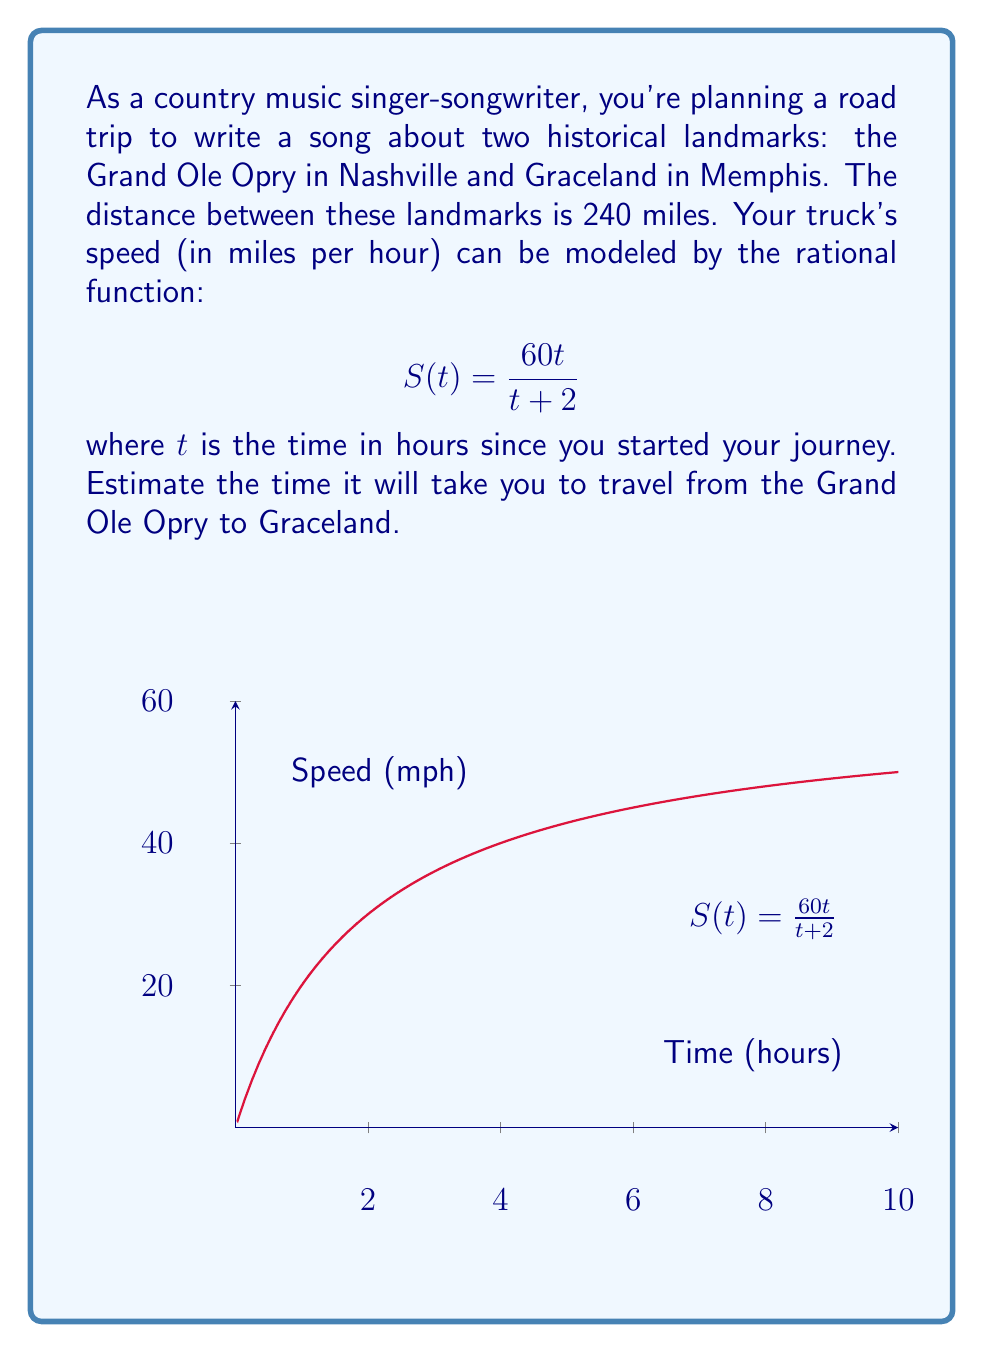Teach me how to tackle this problem. Let's approach this step-by-step:

1) We need to find the time $t$ when the total distance traveled equals 240 miles.

2) The distance traveled is the integral of the speed function:

   $$D(t) = \int_0^t S(u) du = \int_0^t \frac{60u}{u + 2} du$$

3) To solve this integral, we can use the substitution $v = u + 2$:

   $$D(t) = 60 \int_2^{t+2} \frac{v-2}{v} dv = 60 \left[v - 2\ln|v|\right]_2^{t+2}$$

4) Evaluating the integral:

   $$D(t) = 60[(t+2) - 2\ln|t+2| - (2 - 2\ln 2)]$$
   $$D(t) = 60t - 120\ln(t+2) + 120\ln 2$$

5) We want to solve $D(t) = 240$:

   $$240 = 60t - 120\ln(t+2) + 120\ln 2$$

6) This equation can't be solved algebraically. We need to use numerical methods or graphing to estimate the solution.

7) Using a graphing calculator or computer software, we can find that the solution is approximately $t \approx 4.6$ hours.
Answer: Approximately 4.6 hours 